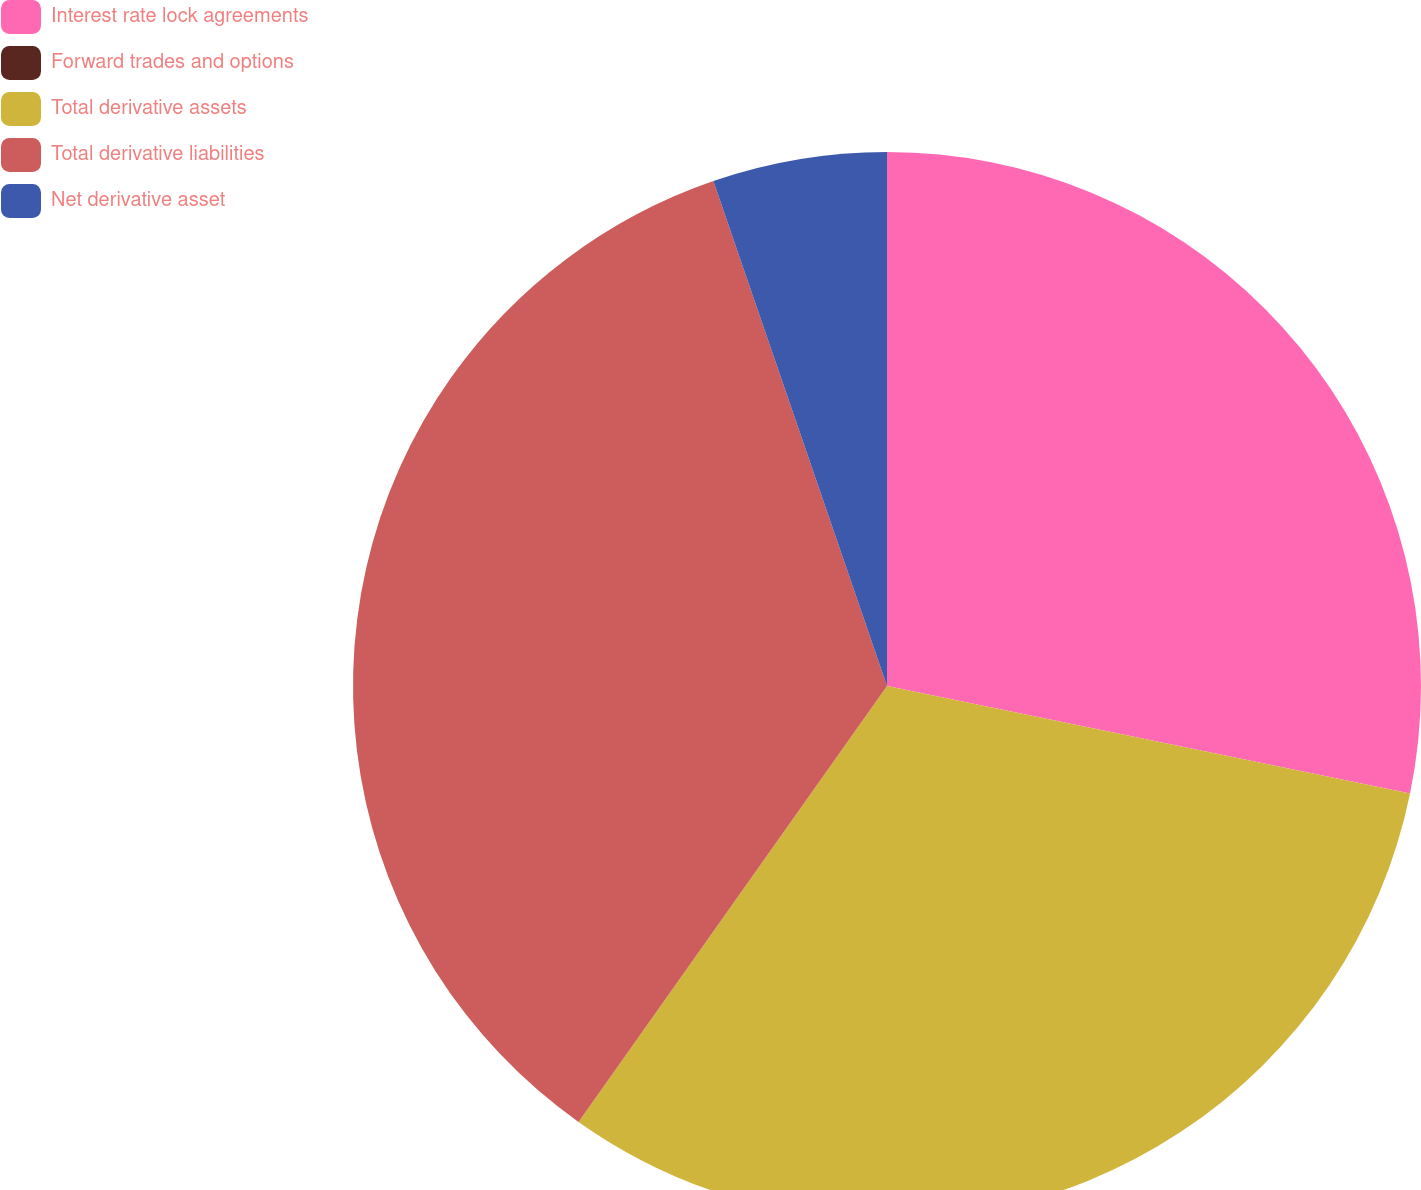<chart> <loc_0><loc_0><loc_500><loc_500><pie_chart><fcel>Interest rate lock agreements<fcel>Forward trades and options<fcel>Total derivative assets<fcel>Total derivative liabilities<fcel>Net derivative asset<nl><fcel>28.22%<fcel>0.0%<fcel>31.57%<fcel>34.92%<fcel>5.27%<nl></chart> 